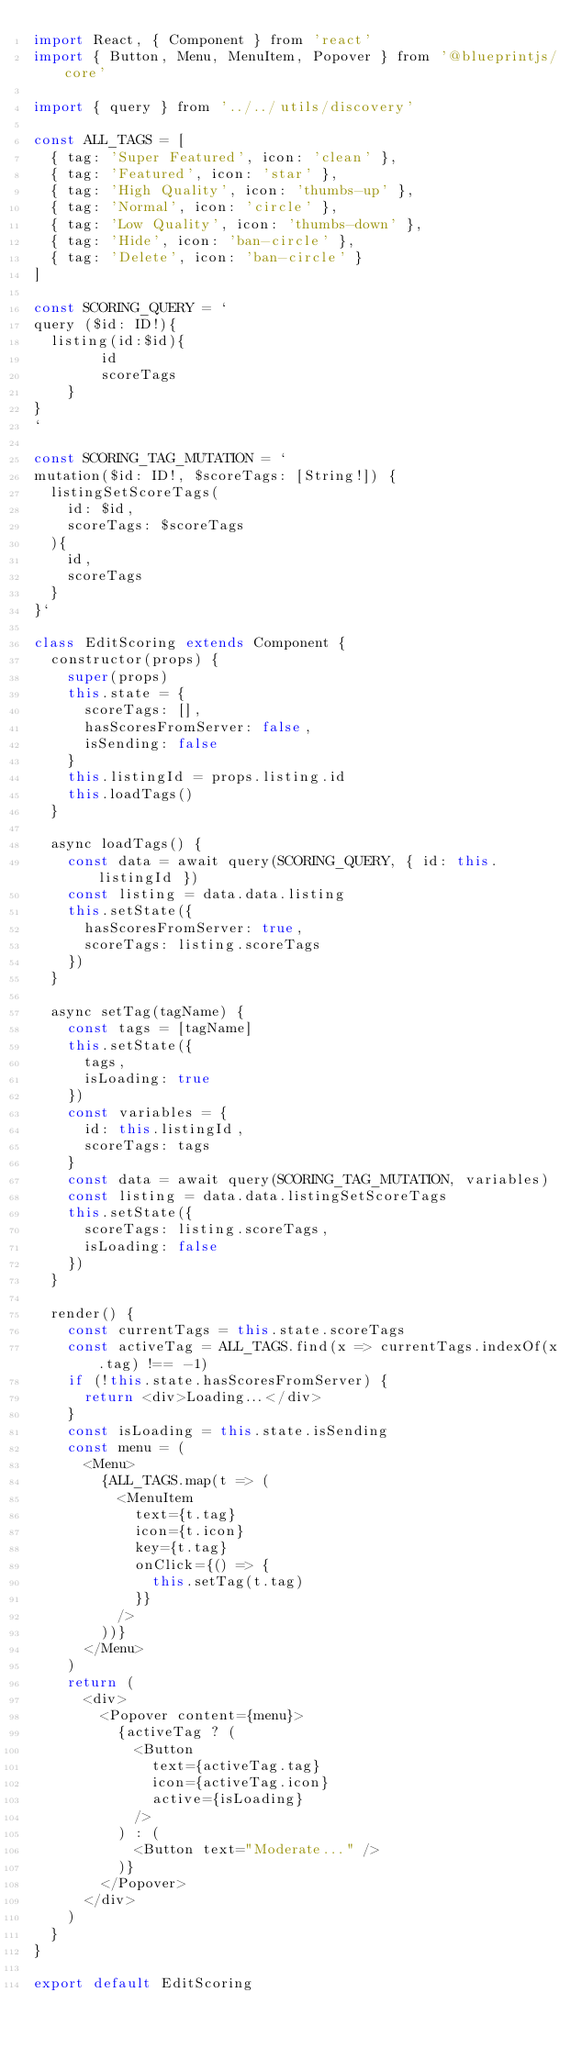<code> <loc_0><loc_0><loc_500><loc_500><_JavaScript_>import React, { Component } from 'react'
import { Button, Menu, MenuItem, Popover } from '@blueprintjs/core'

import { query } from '../../utils/discovery'

const ALL_TAGS = [
  { tag: 'Super Featured', icon: 'clean' },
  { tag: 'Featured', icon: 'star' },
  { tag: 'High Quality', icon: 'thumbs-up' },
  { tag: 'Normal', icon: 'circle' },
  { tag: 'Low Quality', icon: 'thumbs-down' },
  { tag: 'Hide', icon: 'ban-circle' },
  { tag: 'Delete', icon: 'ban-circle' }
]

const SCORING_QUERY = `
query ($id: ID!){
  listing(id:$id){
        id
        scoreTags
    }
}
`

const SCORING_TAG_MUTATION = `
mutation($id: ID!, $scoreTags: [String!]) {
  listingSetScoreTags(
    id: $id,
    scoreTags: $scoreTags
  ){
    id,
    scoreTags
  }
}`

class EditScoring extends Component {
  constructor(props) {
    super(props)
    this.state = {
      scoreTags: [],
      hasScoresFromServer: false,
      isSending: false
    }
    this.listingId = props.listing.id
    this.loadTags()
  }

  async loadTags() {
    const data = await query(SCORING_QUERY, { id: this.listingId })
    const listing = data.data.listing
    this.setState({
      hasScoresFromServer: true,
      scoreTags: listing.scoreTags
    })
  }

  async setTag(tagName) {
    const tags = [tagName]
    this.setState({
      tags,
      isLoading: true
    })
    const variables = {
      id: this.listingId,
      scoreTags: tags
    }
    const data = await query(SCORING_TAG_MUTATION, variables)
    const listing = data.data.listingSetScoreTags
    this.setState({
      scoreTags: listing.scoreTags,
      isLoading: false
    })
  }

  render() {
    const currentTags = this.state.scoreTags
    const activeTag = ALL_TAGS.find(x => currentTags.indexOf(x.tag) !== -1)
    if (!this.state.hasScoresFromServer) {
      return <div>Loading...</div>
    }
    const isLoading = this.state.isSending
    const menu = (
      <Menu>
        {ALL_TAGS.map(t => (
          <MenuItem
            text={t.tag}
            icon={t.icon}
            key={t.tag}
            onClick={() => {
              this.setTag(t.tag)
            }}
          />
        ))}
      </Menu>
    )
    return (
      <div>
        <Popover content={menu}>
          {activeTag ? (
            <Button
              text={activeTag.tag}
              icon={activeTag.icon}
              active={isLoading}
            />
          ) : (
            <Button text="Moderate..." />
          )}
        </Popover>
      </div>
    )
  }
}

export default EditScoring
</code> 